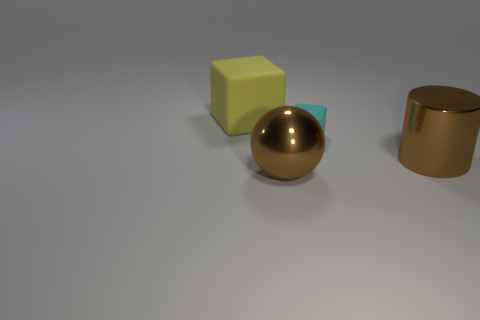Add 3 rubber things. How many objects exist? 7 Subtract all balls. How many objects are left? 3 Subtract all tiny blue cubes. Subtract all cyan things. How many objects are left? 3 Add 1 tiny cubes. How many tiny cubes are left? 2 Add 2 large gray rubber objects. How many large gray rubber objects exist? 2 Subtract 0 yellow cylinders. How many objects are left? 4 